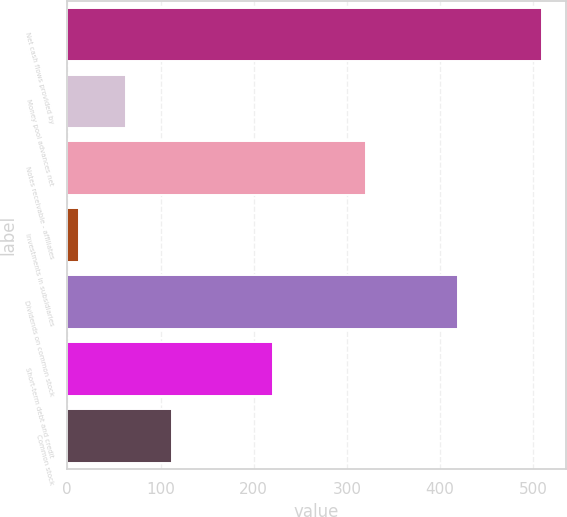Convert chart to OTSL. <chart><loc_0><loc_0><loc_500><loc_500><bar_chart><fcel>Net cash flows provided by<fcel>Money pool advances net<fcel>Notes receivable - affiliates<fcel>Investments in subsidiaries<fcel>Dividends on common stock<fcel>Short-term debt and credit<fcel>Common stock<nl><fcel>509<fcel>62.6<fcel>320.2<fcel>13<fcel>419.4<fcel>221<fcel>112.2<nl></chart> 